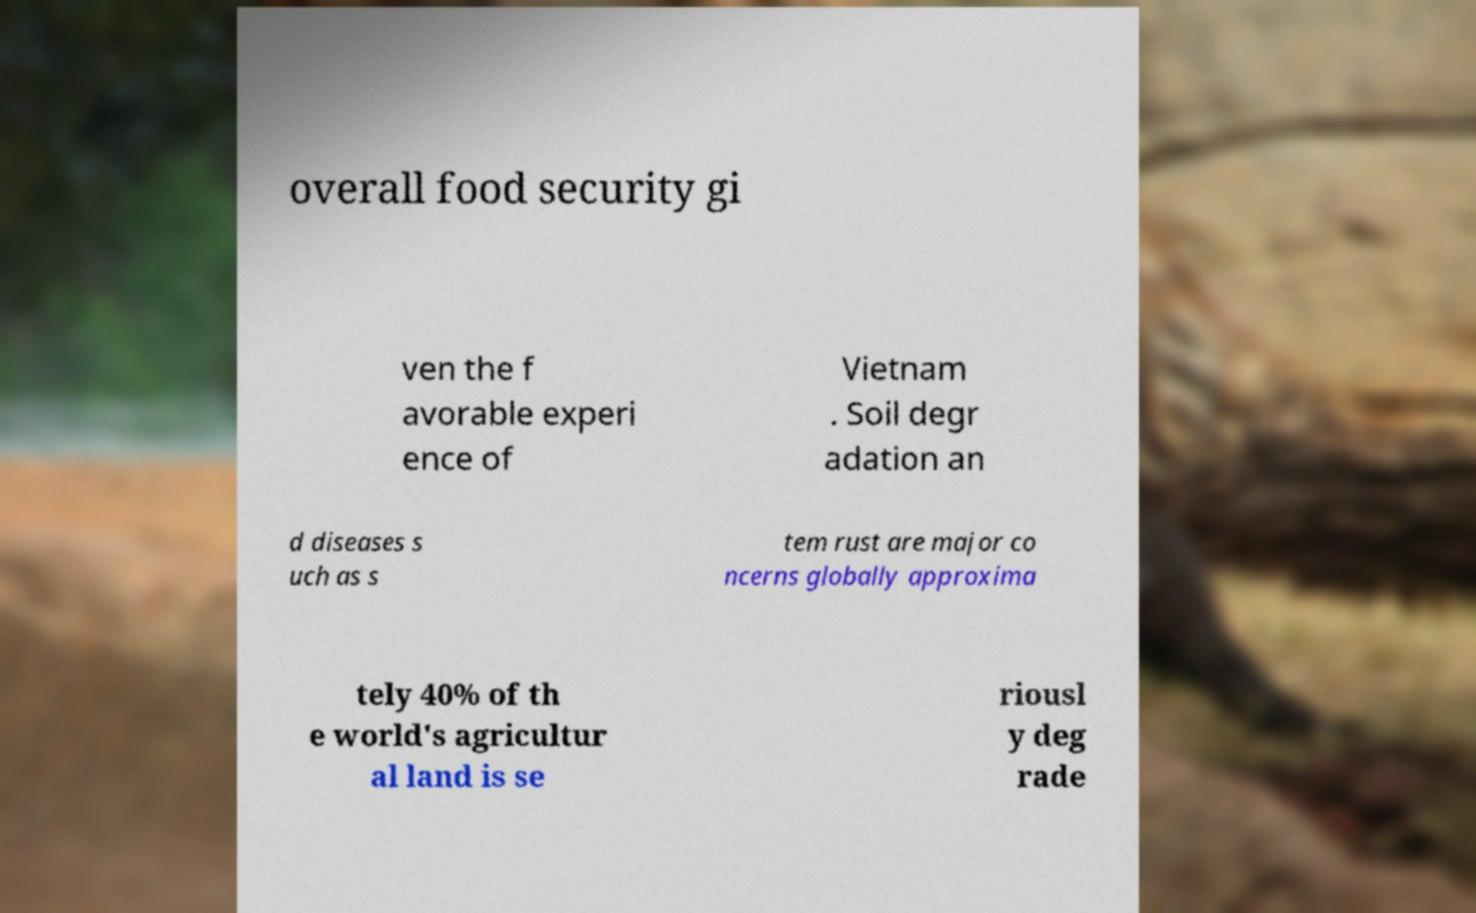Can you read and provide the text displayed in the image?This photo seems to have some interesting text. Can you extract and type it out for me? overall food security gi ven the f avorable experi ence of Vietnam . Soil degr adation an d diseases s uch as s tem rust are major co ncerns globally approxima tely 40% of th e world's agricultur al land is se riousl y deg rade 